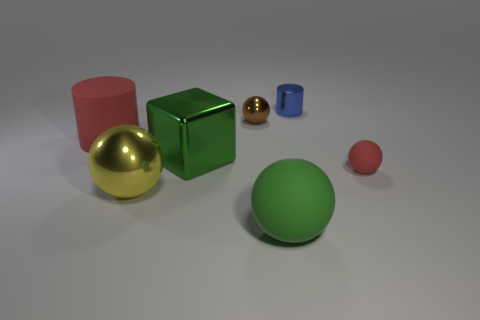What is the shape of the metallic object that is behind the small ball to the left of the blue metal object?
Your answer should be very brief. Cylinder. What shape is the green shiny object that is the same size as the green matte object?
Ensure brevity in your answer.  Cube. Is there a small thing of the same color as the cube?
Your answer should be very brief. No. Is the number of large yellow spheres behind the large green metal object the same as the number of small brown metal spheres in front of the large rubber cylinder?
Keep it short and to the point. Yes. There is a tiny red thing; is it the same shape as the big matte object that is left of the tiny metal ball?
Offer a very short reply. No. What number of other objects are the same material as the yellow ball?
Provide a succinct answer. 3. There is a big cube; are there any small brown shiny balls on the right side of it?
Your response must be concise. Yes. There is a yellow metallic ball; is it the same size as the red rubber thing behind the small rubber thing?
Offer a terse response. Yes. There is a small thing that is behind the tiny sphere left of the tiny blue thing; what is its color?
Provide a succinct answer. Blue. Is the green rubber ball the same size as the red matte ball?
Make the answer very short. No. 